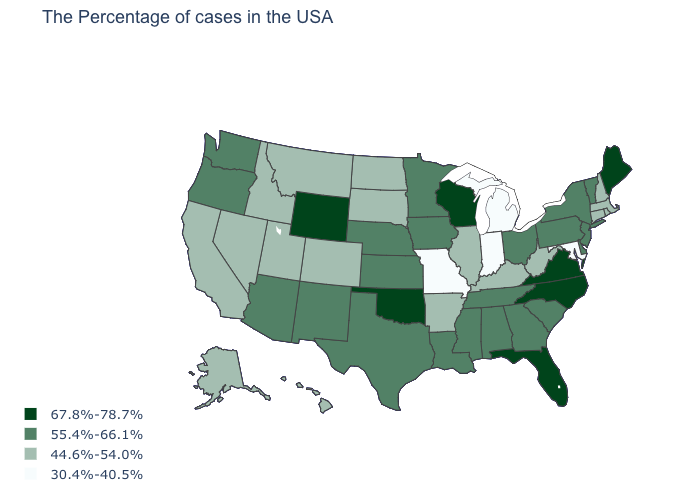What is the value of South Dakota?
Answer briefly. 44.6%-54.0%. Name the states that have a value in the range 44.6%-54.0%?
Short answer required. Massachusetts, Rhode Island, New Hampshire, Connecticut, West Virginia, Kentucky, Illinois, Arkansas, South Dakota, North Dakota, Colorado, Utah, Montana, Idaho, Nevada, California, Alaska, Hawaii. How many symbols are there in the legend?
Quick response, please. 4. Which states have the lowest value in the USA?
Keep it brief. Maryland, Michigan, Indiana, Missouri. Which states have the lowest value in the West?
Short answer required. Colorado, Utah, Montana, Idaho, Nevada, California, Alaska, Hawaii. Which states have the highest value in the USA?
Quick response, please. Maine, Virginia, North Carolina, Florida, Wisconsin, Oklahoma, Wyoming. Name the states that have a value in the range 30.4%-40.5%?
Concise answer only. Maryland, Michigan, Indiana, Missouri. Name the states that have a value in the range 44.6%-54.0%?
Concise answer only. Massachusetts, Rhode Island, New Hampshire, Connecticut, West Virginia, Kentucky, Illinois, Arkansas, South Dakota, North Dakota, Colorado, Utah, Montana, Idaho, Nevada, California, Alaska, Hawaii. Does South Carolina have a lower value than North Dakota?
Short answer required. No. Does Ohio have the same value as Michigan?
Short answer required. No. Does the first symbol in the legend represent the smallest category?
Answer briefly. No. What is the value of New Mexico?
Be succinct. 55.4%-66.1%. Does Connecticut have a higher value than North Carolina?
Give a very brief answer. No. Name the states that have a value in the range 44.6%-54.0%?
Give a very brief answer. Massachusetts, Rhode Island, New Hampshire, Connecticut, West Virginia, Kentucky, Illinois, Arkansas, South Dakota, North Dakota, Colorado, Utah, Montana, Idaho, Nevada, California, Alaska, Hawaii. Name the states that have a value in the range 67.8%-78.7%?
Give a very brief answer. Maine, Virginia, North Carolina, Florida, Wisconsin, Oklahoma, Wyoming. 